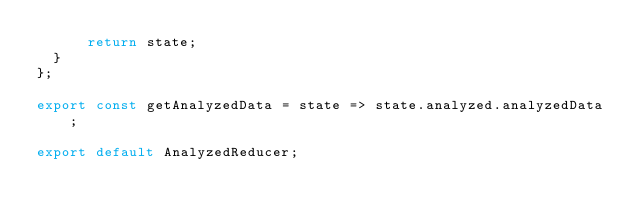<code> <loc_0><loc_0><loc_500><loc_500><_JavaScript_>      return state;
  }
};

export const getAnalyzedData = state => state.analyzed.analyzedData;

export default AnalyzedReducer;
</code> 